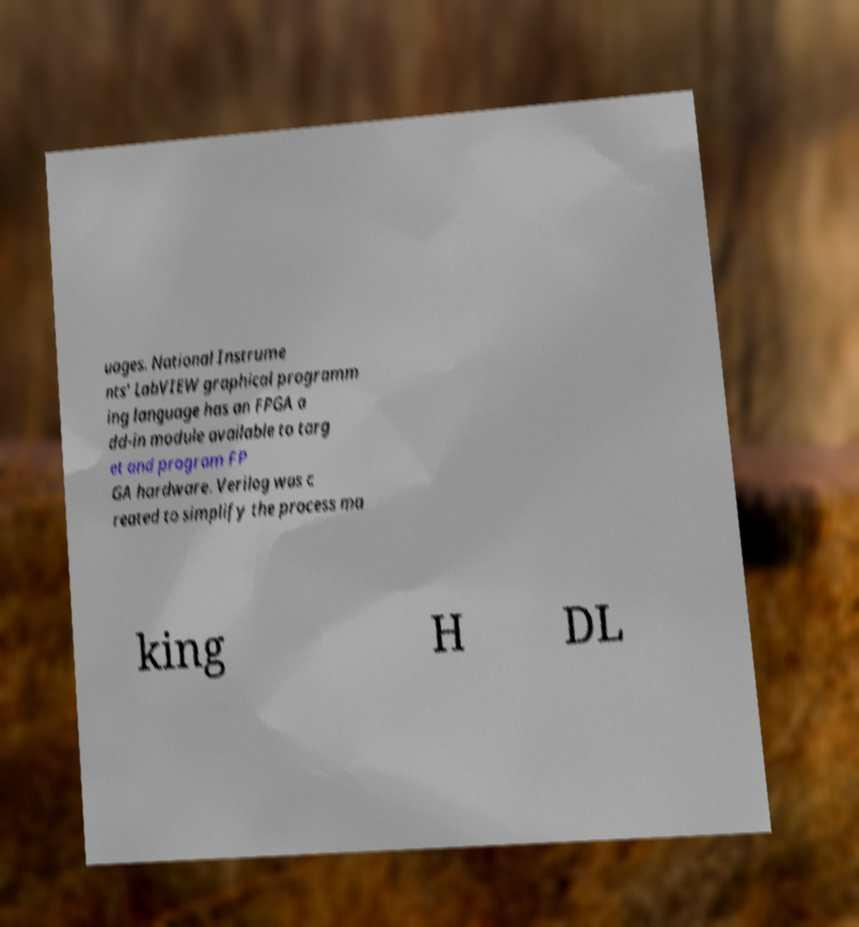I need the written content from this picture converted into text. Can you do that? uages. National Instrume nts' LabVIEW graphical programm ing language has an FPGA a dd-in module available to targ et and program FP GA hardware. Verilog was c reated to simplify the process ma king H DL 